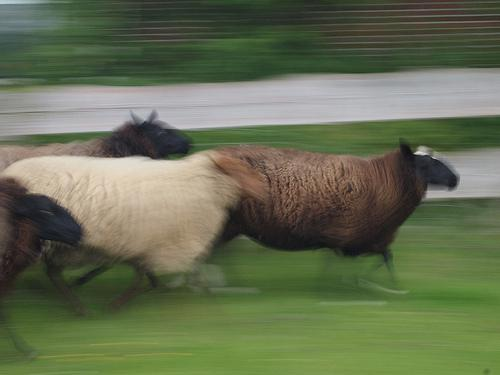Question: how many sheep are visible?
Choices:
A. Two.
B. Six.
C. Four.
D. Five.
Answer with the letter. Answer: C Question: what are these sheep doing?
Choices:
A. Grazing.
B. Sleeping.
C. Running.
D. Playing.
Answer with the letter. Answer: C Question: how many sheep are brown?
Choices:
A. One.
B. Five.
C. Three.
D. Six.
Answer with the letter. Answer: C Question: where was this photo taken?
Choices:
A. On a dry desert.
B. In the rainforest.
C. In a mud pit.
D. Outside in a grassy area.
Answer with the letter. Answer: D Question: why is this picture blurry?
Choices:
A. Because the camera was moving.
B. Because the film was old.
C. Because the sheep are in motion.
D. Had the wrong film.
Answer with the letter. Answer: C 